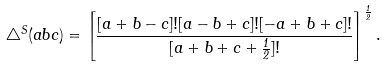Convert formula to latex. <formula><loc_0><loc_0><loc_500><loc_500>\bigtriangleup ^ { S } ( a b c ) = \left [ \frac { [ a + b - c ] ! [ a - b + c ] ! [ - a + b + c ] ! } { [ a + b + c + \frac { 1 } { 2 } ] ! } \right ] ^ { \frac { 1 } { 2 } } .</formula> 